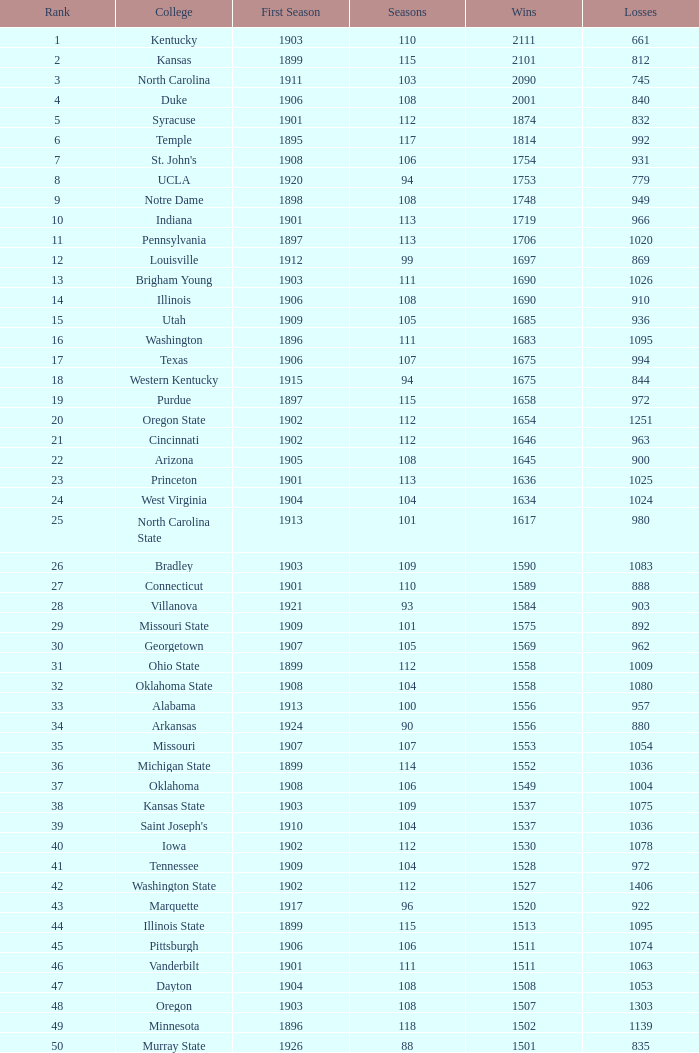What is the total of First Season games with 1537 Wins and a Season greater than 109? None. 